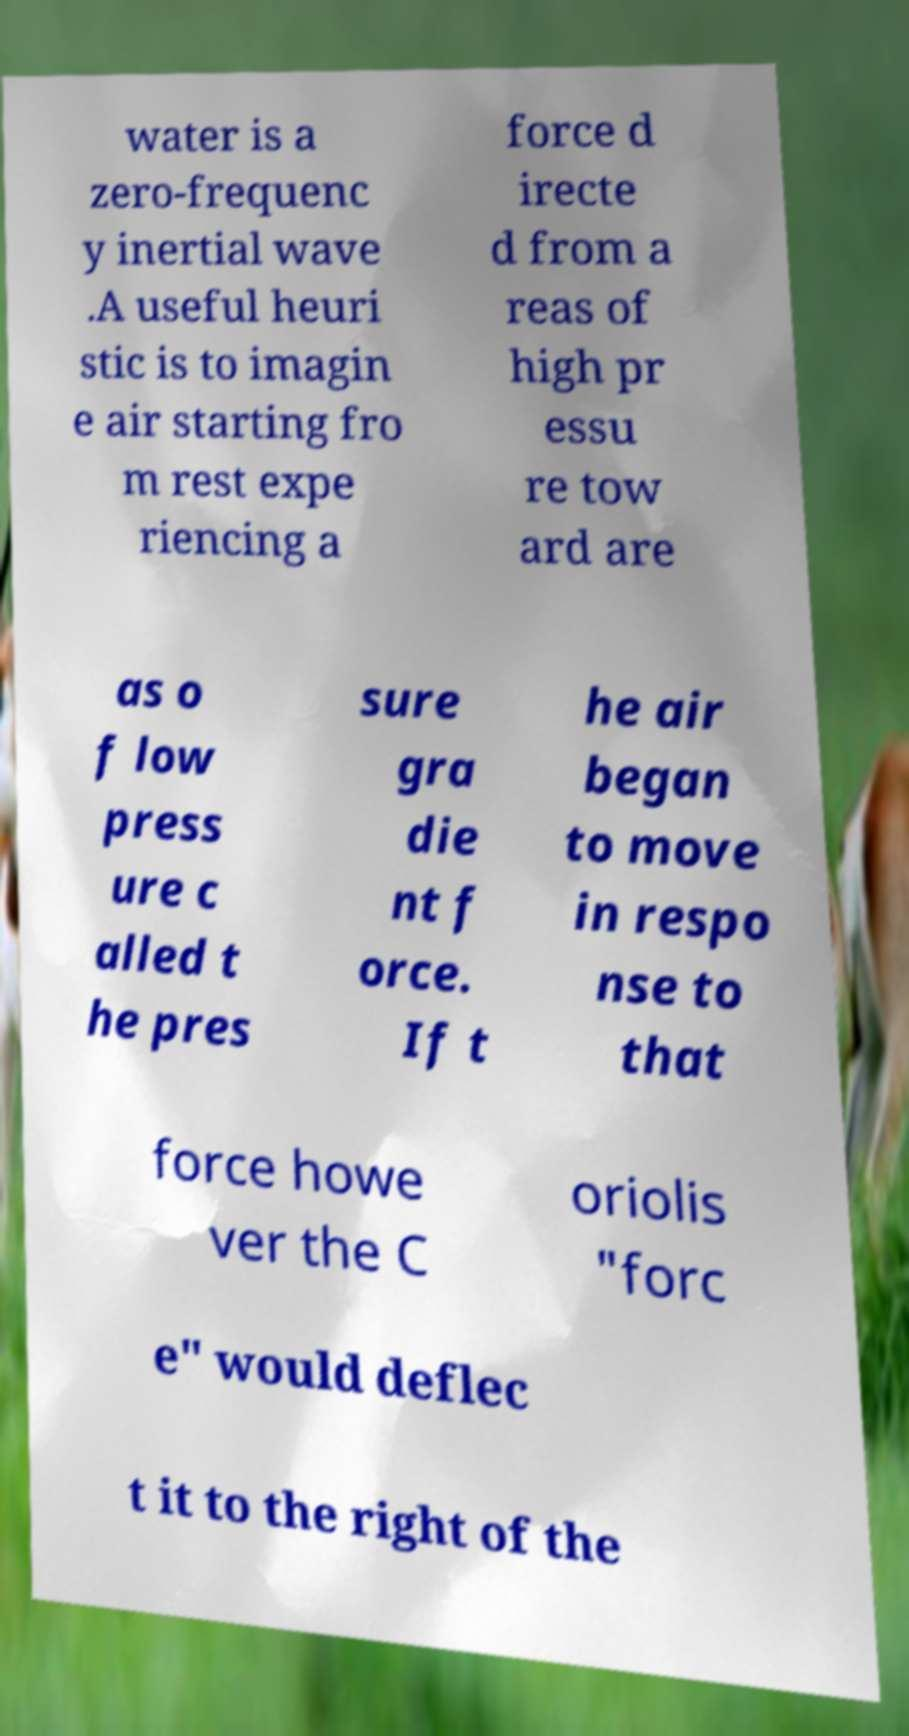I need the written content from this picture converted into text. Can you do that? water is a zero-frequenc y inertial wave .A useful heuri stic is to imagin e air starting fro m rest expe riencing a force d irecte d from a reas of high pr essu re tow ard are as o f low press ure c alled t he pres sure gra die nt f orce. If t he air began to move in respo nse to that force howe ver the C oriolis "forc e" would deflec t it to the right of the 